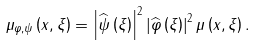Convert formula to latex. <formula><loc_0><loc_0><loc_500><loc_500>\mu _ { \varphi , \psi } \left ( x , \xi \right ) = \left | \widehat { \psi } \left ( \xi \right ) \right | ^ { 2 } \left | \widehat { \varphi } \left ( \xi \right ) \right | ^ { 2 } \mu \left ( x , \xi \right ) .</formula> 